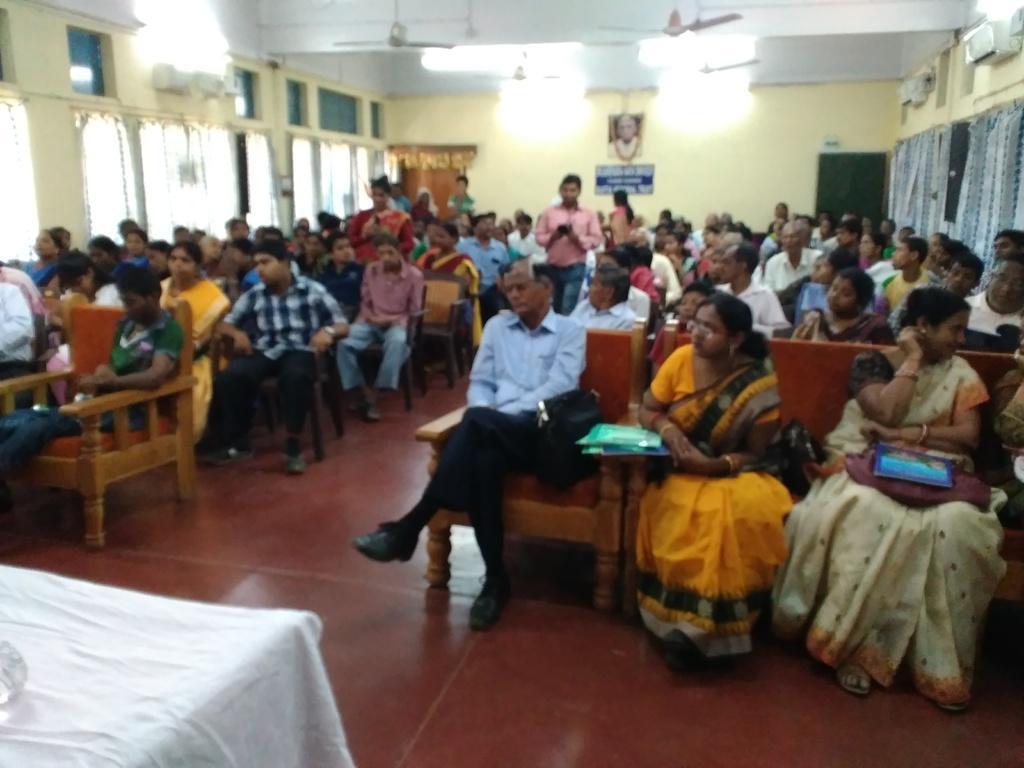In one or two sentences, can you explain what this image depicts? As we can see in the image there is a wall, photo frame, few people sitting on chairs and in the front there is a table. 